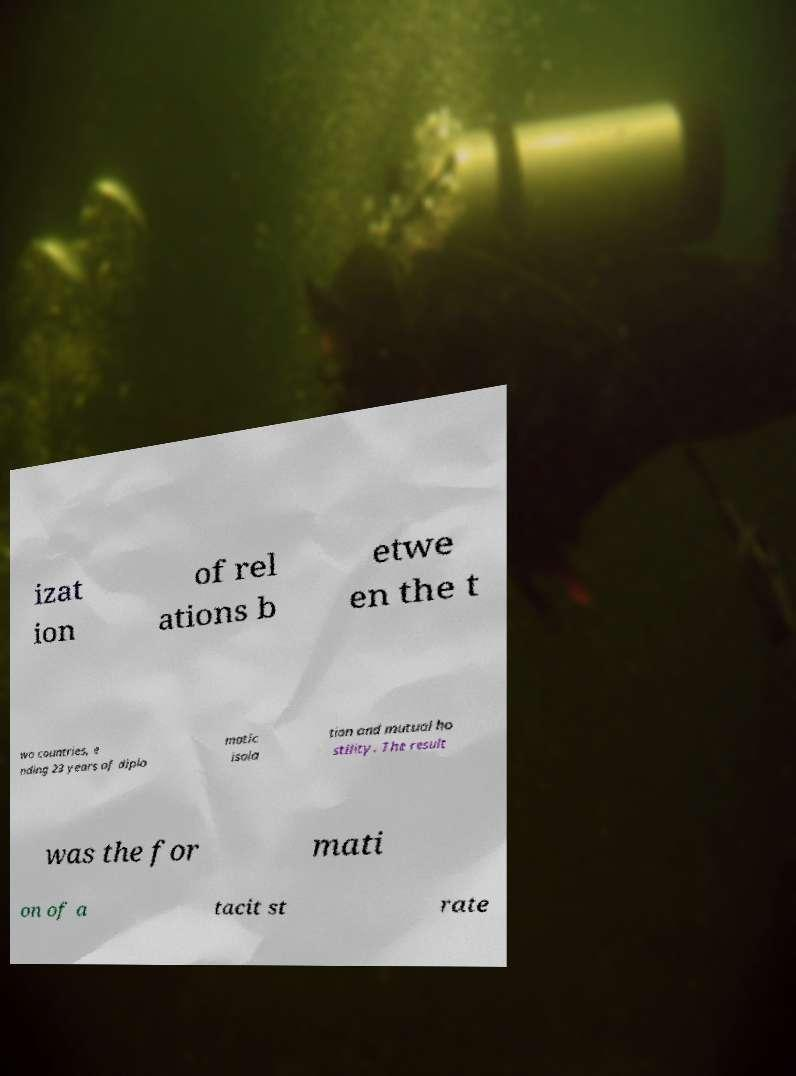For documentation purposes, I need the text within this image transcribed. Could you provide that? izat ion of rel ations b etwe en the t wo countries, e nding 23 years of diplo matic isola tion and mutual ho stility. The result was the for mati on of a tacit st rate 